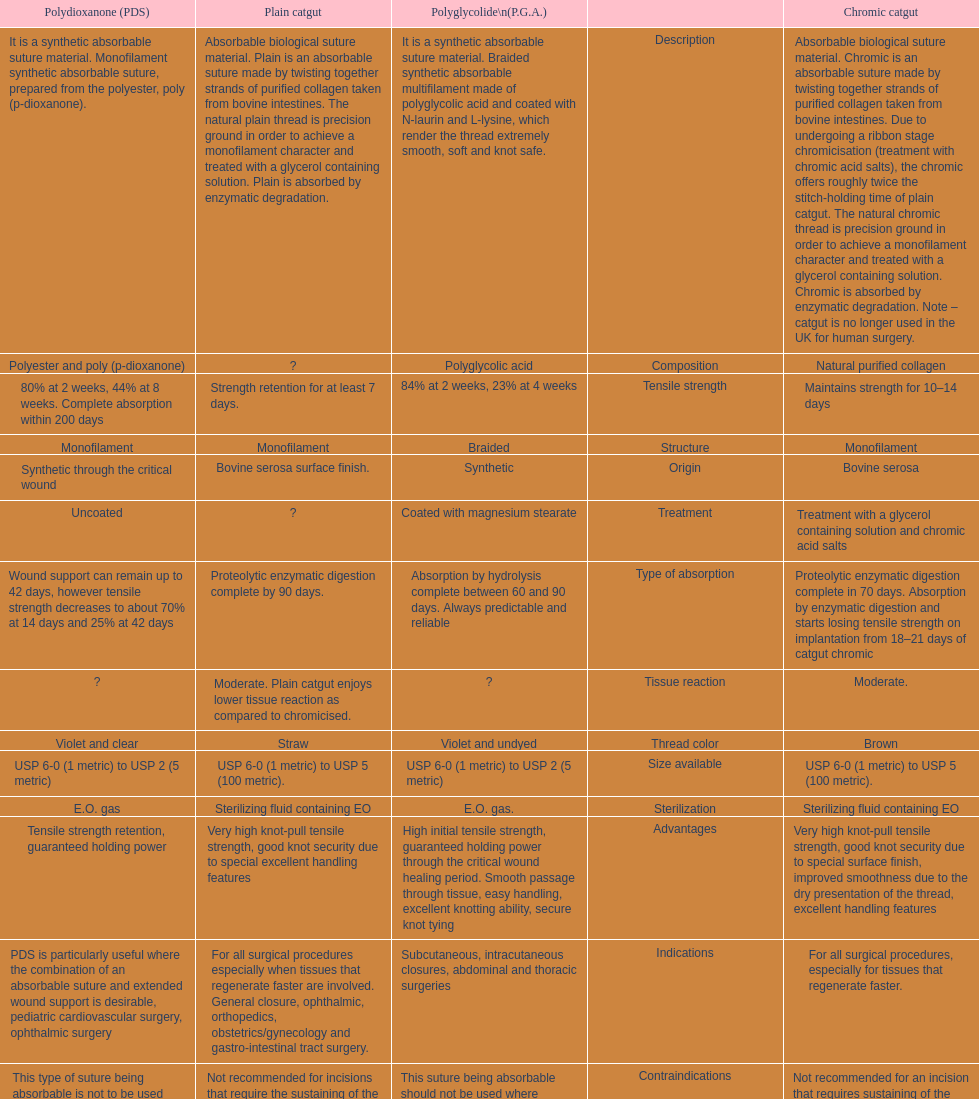Could you parse the entire table? {'header': ['Polydioxanone (PDS)', 'Plain catgut', 'Polyglycolide\\n(P.G.A.)', '', 'Chromic catgut'], 'rows': [['It is a synthetic absorbable suture material. Monofilament synthetic absorbable suture, prepared from the polyester, poly (p-dioxanone).', 'Absorbable biological suture material. Plain is an absorbable suture made by twisting together strands of purified collagen taken from bovine intestines. The natural plain thread is precision ground in order to achieve a monofilament character and treated with a glycerol containing solution. Plain is absorbed by enzymatic degradation.', 'It is a synthetic absorbable suture material. Braided synthetic absorbable multifilament made of polyglycolic acid and coated with N-laurin and L-lysine, which render the thread extremely smooth, soft and knot safe.', 'Description', 'Absorbable biological suture material. Chromic is an absorbable suture made by twisting together strands of purified collagen taken from bovine intestines. Due to undergoing a ribbon stage chromicisation (treatment with chromic acid salts), the chromic offers roughly twice the stitch-holding time of plain catgut. The natural chromic thread is precision ground in order to achieve a monofilament character and treated with a glycerol containing solution. Chromic is absorbed by enzymatic degradation. Note – catgut is no longer used in the UK for human surgery.'], ['Polyester and poly (p-dioxanone)', '?', 'Polyglycolic acid', 'Composition', 'Natural purified collagen'], ['80% at 2 weeks, 44% at 8 weeks. Complete absorption within 200 days', 'Strength retention for at least 7 days.', '84% at 2 weeks, 23% at 4 weeks', 'Tensile strength', 'Maintains strength for 10–14 days'], ['Monofilament', 'Monofilament', 'Braided', 'Structure', 'Monofilament'], ['Synthetic through the critical wound', 'Bovine serosa surface finish.', 'Synthetic', 'Origin', 'Bovine serosa'], ['Uncoated', '?', 'Coated with magnesium stearate', 'Treatment', 'Treatment with a glycerol containing solution and chromic acid salts'], ['Wound support can remain up to 42 days, however tensile strength decreases to about 70% at 14 days and 25% at 42 days', 'Proteolytic enzymatic digestion complete by 90 days.', 'Absorption by hydrolysis complete between 60 and 90 days. Always predictable and reliable', 'Type of absorption', 'Proteolytic enzymatic digestion complete in 70 days. Absorption by enzymatic digestion and starts losing tensile strength on implantation from 18–21 days of catgut chromic'], ['?', 'Moderate. Plain catgut enjoys lower tissue reaction as compared to chromicised.', '?', 'Tissue reaction', 'Moderate.'], ['Violet and clear', 'Straw', 'Violet and undyed', 'Thread color', 'Brown'], ['USP 6-0 (1 metric) to USP 2 (5 metric)', 'USP 6-0 (1 metric) to USP 5 (100 metric).', 'USP 6-0 (1 metric) to USP 2 (5 metric)', 'Size available', 'USP 6-0 (1 metric) to USP 5 (100 metric).'], ['E.O. gas', 'Sterilizing fluid containing EO', 'E.O. gas.', 'Sterilization', 'Sterilizing fluid containing EO'], ['Tensile strength retention, guaranteed holding power', 'Very high knot-pull tensile strength, good knot security due to special excellent handling features', 'High initial tensile strength, guaranteed holding power through the critical wound healing period. Smooth passage through tissue, easy handling, excellent knotting ability, secure knot tying', 'Advantages', 'Very high knot-pull tensile strength, good knot security due to special surface finish, improved smoothness due to the dry presentation of the thread, excellent handling features'], ['PDS is particularly useful where the combination of an absorbable suture and extended wound support is desirable, pediatric cardiovascular surgery, ophthalmic surgery', 'For all surgical procedures especially when tissues that regenerate faster are involved. General closure, ophthalmic, orthopedics, obstetrics/gynecology and gastro-intestinal tract surgery.', 'Subcutaneous, intracutaneous closures, abdominal and thoracic surgeries', 'Indications', 'For all surgical procedures, especially for tissues that regenerate faster.'], ['This type of suture being absorbable is not to be used where prolonged approximation of tissues under stress is required and/ or in conjunction with prosthetic devices', 'Not recommended for incisions that require the sustaining of the tissues for a prolonged period of time.', 'This suture being absorbable should not be used where extended approximation of tissue is required.', 'Contraindications', 'Not recommended for an incision that requires sustaining of the tissues for a prolonged period of time.'], ['The PDS suture knots must be properly placed to be secure. Conjunctival and vaginal mucosal sutures remaining in place for extended periods may be associated with localized irritation. Subcuticular sutures should be placed as deeply as possible in order to minimize the erythema and induration normally associated with absorption.', 'Special precautions should be taken in patients with cancer, anemia and malnutrition conditions. They tend to absorb the sutures at a higher rate. Cardiovascular surgery, due to the continued heart contractions. It is absorbed much faster when used in the mouth and in the vagina, due to the presence of microorganisms. Avoid using where long term tissue approximation is needed. Absorption is faster in infected tissues', 'Special precautions should be taken in elderly patients and patients with history of anemia and malnutrition conditions. As with any suture material, adequate knot security requires the accepted surgical technique of flat and square ties.', 'Precautions', 'It is absorbed much faster when used in the mouth and in the vagina, due to the presence of microorganism. Cardiovascular surgery, due to the continued heart contractions. Special precautions should be taken in patients with cancer, anemia and malnutrition conditions. They tend to absorb this suture at a higher rate.']]} What type of sutures are no longer used in the u.k. for human surgery? Chromic catgut. 